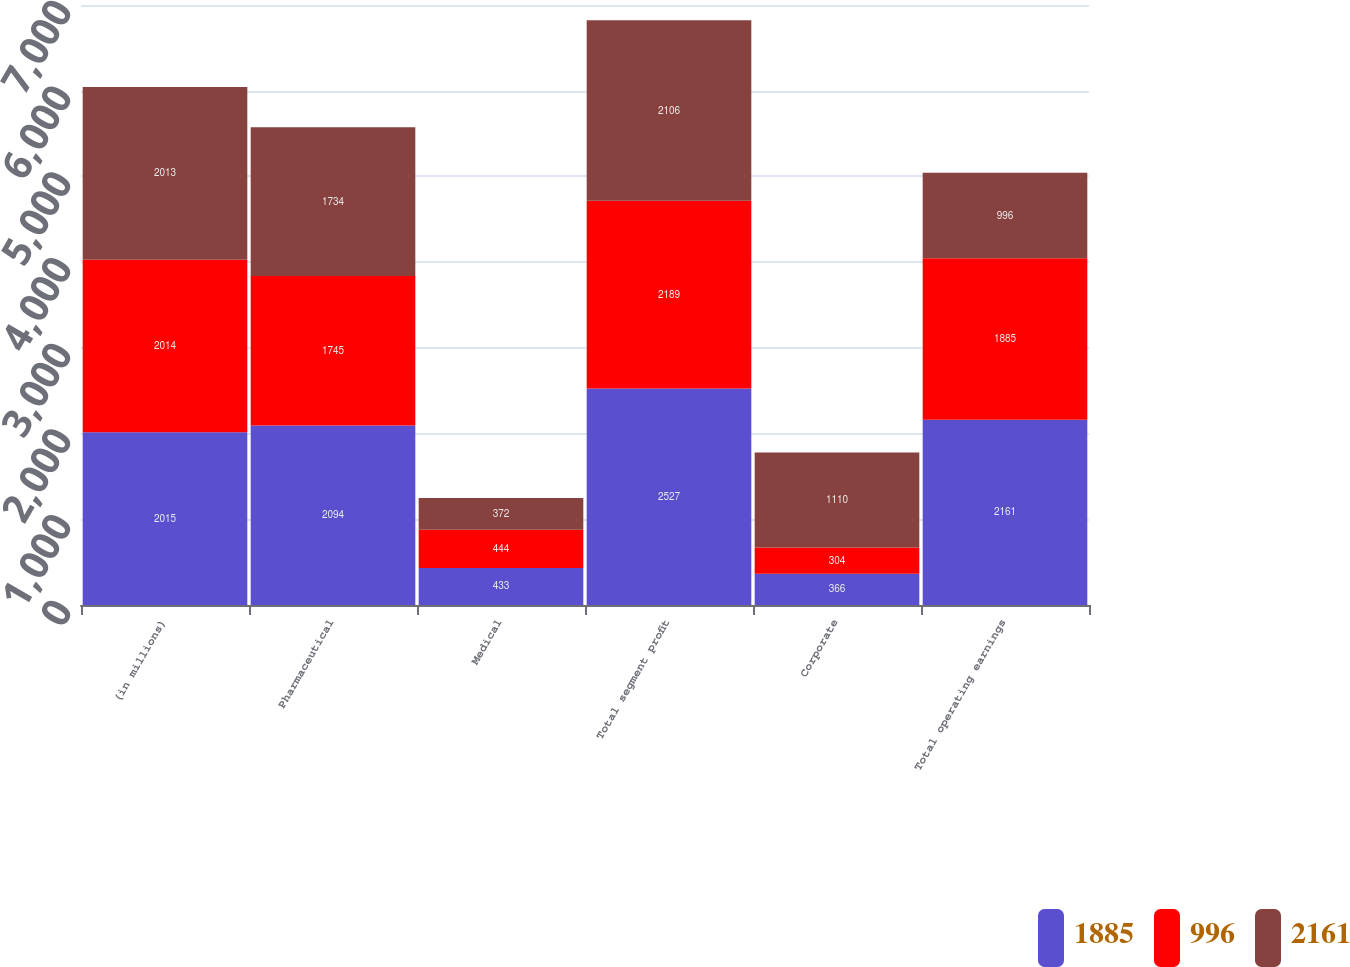Convert chart. <chart><loc_0><loc_0><loc_500><loc_500><stacked_bar_chart><ecel><fcel>(in millions)<fcel>Pharmaceutical<fcel>Medical<fcel>Total segment profit<fcel>Corporate<fcel>Total operating earnings<nl><fcel>1885<fcel>2015<fcel>2094<fcel>433<fcel>2527<fcel>366<fcel>2161<nl><fcel>996<fcel>2014<fcel>1745<fcel>444<fcel>2189<fcel>304<fcel>1885<nl><fcel>2161<fcel>2013<fcel>1734<fcel>372<fcel>2106<fcel>1110<fcel>996<nl></chart> 